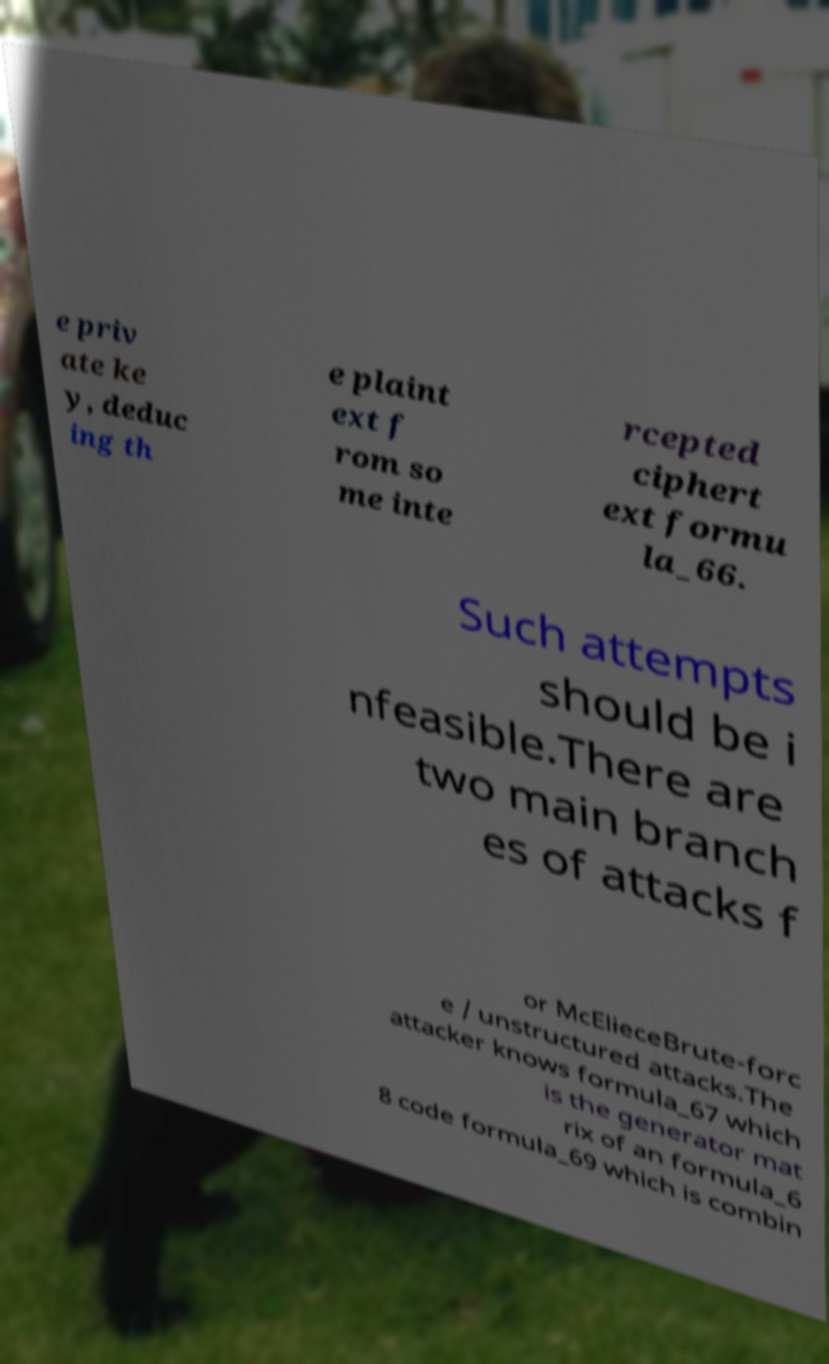Please read and relay the text visible in this image. What does it say? e priv ate ke y, deduc ing th e plaint ext f rom so me inte rcepted ciphert ext formu la_66. Such attempts should be i nfeasible.There are two main branch es of attacks f or McElieceBrute-forc e / unstructured attacks.The attacker knows formula_67 which is the generator mat rix of an formula_6 8 code formula_69 which is combin 